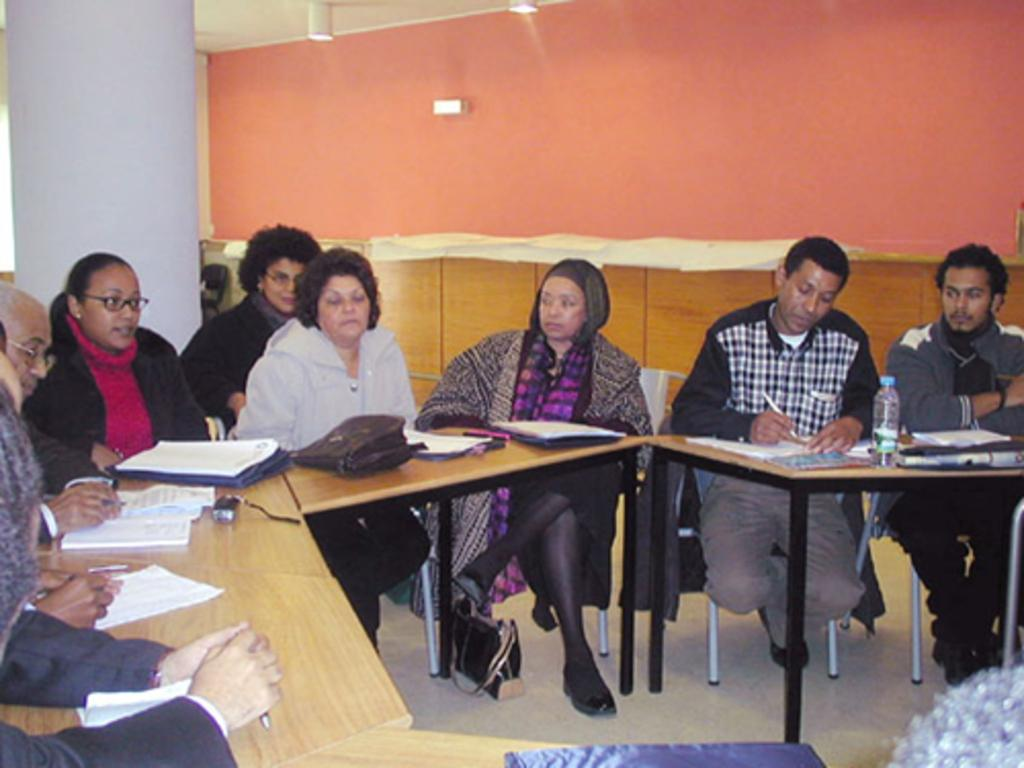How many people are in the image? There is a group of people in the image. What are the people doing in the image? The people are sitting on chairs. What items can be seen on the table in the image? There are books, bags, and a bottle on the table. What is visible in the background of the image? There is a wall in the image. What type of discussion is taking place in the image? There is no indication of a discussion taking place in the image. Can you tell me how many people were born during the event in the image? There is no event or birth depicted in the image. 